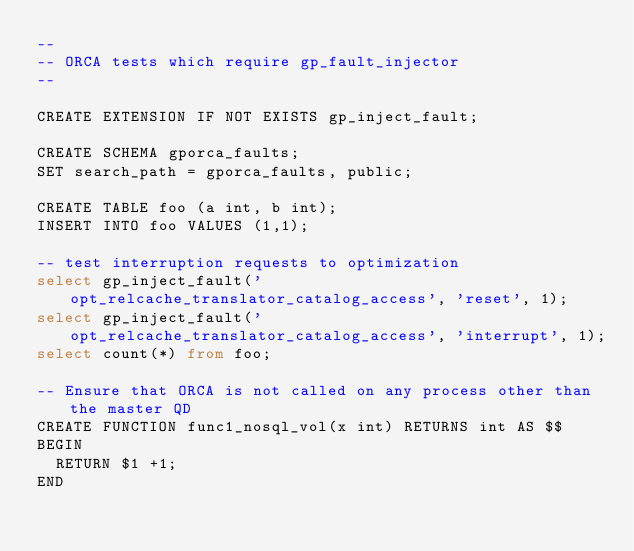<code> <loc_0><loc_0><loc_500><loc_500><_SQL_>--
-- ORCA tests which require gp_fault_injector
--

CREATE EXTENSION IF NOT EXISTS gp_inject_fault;

CREATE SCHEMA gporca_faults;
SET search_path = gporca_faults, public;

CREATE TABLE foo (a int, b int);
INSERT INTO foo VALUES (1,1);

-- test interruption requests to optimization
select gp_inject_fault('opt_relcache_translator_catalog_access', 'reset', 1);
select gp_inject_fault('opt_relcache_translator_catalog_access', 'interrupt', 1);
select count(*) from foo;

-- Ensure that ORCA is not called on any process other than the master QD
CREATE FUNCTION func1_nosql_vol(x int) RETURNS int AS $$
BEGIN
  RETURN $1 +1;
END</code> 